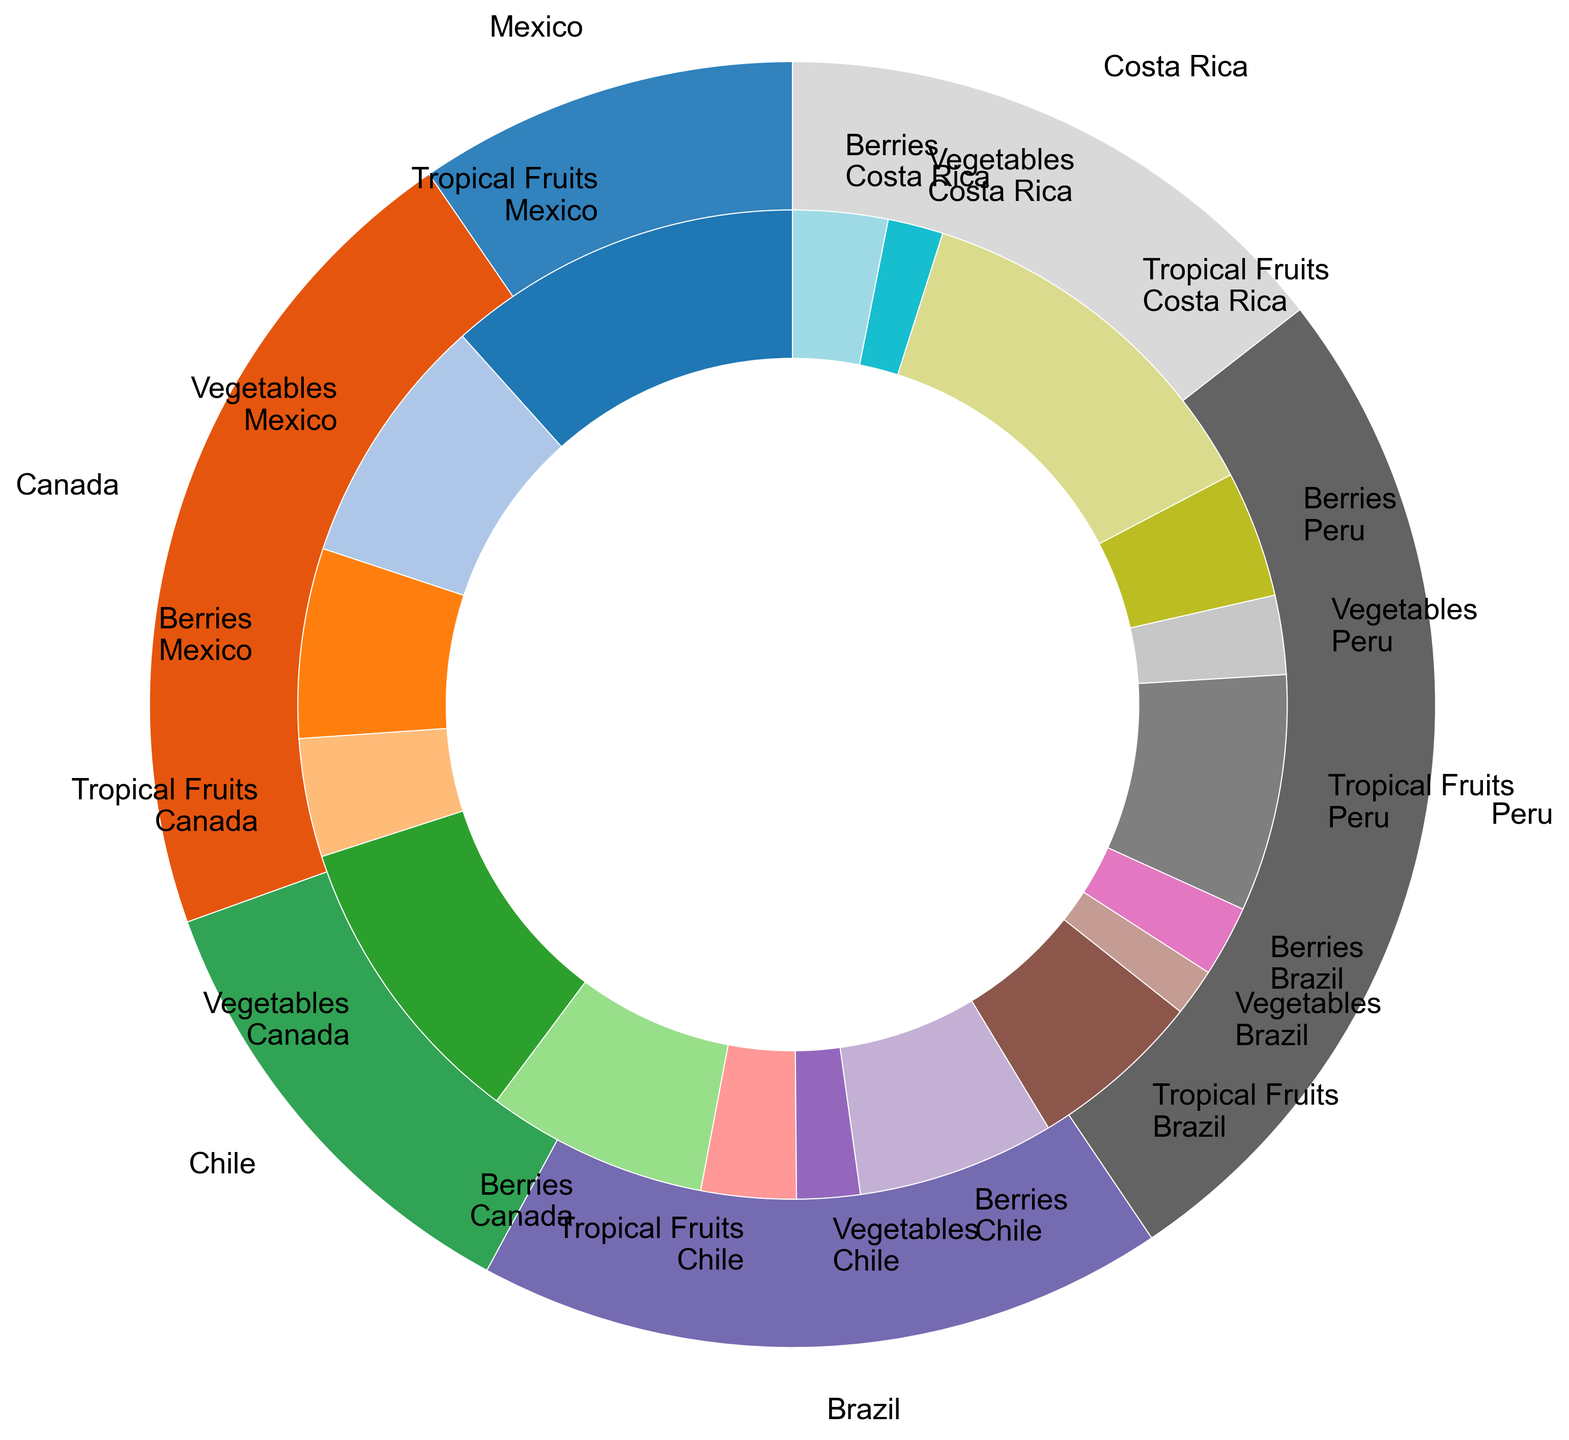Which country imports the highest value of tropical fruits to the US? First, look at the outer pie to identify the countries contributing to the imports. Then, among the slices representing tropical fruits in the respective countries, compare their sizes. The largest slice will indicate the highest value. Costa Rica's tropical fruit slice is the largest.
Answer: Costa Rica Which country has a higher total import value, Mexico or Canada? Determine the total import value by examining the size of the outer slices for Mexico and Canada. Compare the sizes of these two slices. The slice for Mexico is slightly larger than for Canada.
Answer: Mexico What is the combined import value of berries from Chile and Peru? Identify the inner slices representing berries for both Chile and Peru. Sum their values: Chile (2500) and Peru (1600). Combined value = 2500 + 1600 = 4100.
Answer: 4100 Between Costa Rica and Brazil, which country imports a larger amount of vegetables, and what is the difference in their import values? Compare the inner slices for vegetables from Costa Rica and Brazil. Costa Rica's vegetable slice is larger. Difference = Costa Rica (700) - Brazil (600) = 100.
Answer: Costa Rica, 100 Which produce type has the lowest import value from Brazil? Look at Brazil's inner slices and compare their sizes. The smallest slice represents vegetables.
Answer: Vegetables How much more value of vegetables does Canada import compared to Peru? Compare the inner slices representing vegetables from Canada and Peru. Difference = Canada (3800) - Peru (1000) = 2800.
Answer: 2800 Which country contributes equally to the imports of tropical fruits and berries? Identify the countries by comparing the inner slices for tropical fruits and berries. Chile has slices of equal size for these produce types (1200 tropical fruits, 2500 berries, not equal, so check again). None of the countries has equal import values for both produce types.
Answer: None What is the value difference between the largest and smallest imports of tropical fruits among all countries? Compare the inner slices for tropical fruits from all countries. Largest = Costa Rica (4800), Smallest = Chile (1200). Difference = 4800 - 1200 = 3600.
Answer: 3600 